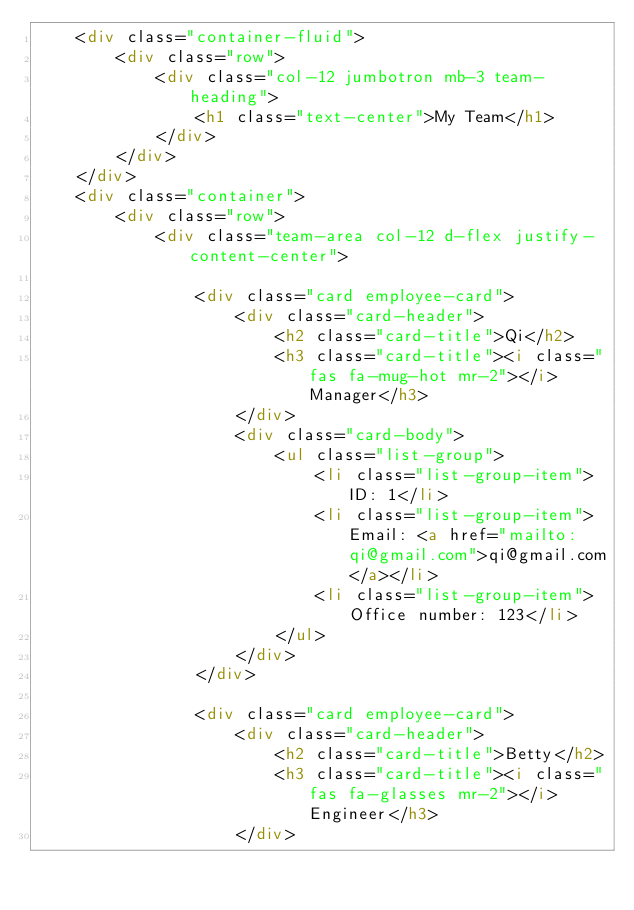<code> <loc_0><loc_0><loc_500><loc_500><_HTML_>    <div class="container-fluid">
        <div class="row">
            <div class="col-12 jumbotron mb-3 team-heading">
                <h1 class="text-center">My Team</h1>
            </div>
        </div>
    </div>
    <div class="container">
        <div class="row">
            <div class="team-area col-12 d-flex justify-content-center">

                <div class="card employee-card">
                    <div class="card-header">
                        <h2 class="card-title">Qi</h2>
                        <h3 class="card-title"><i class="fas fa-mug-hot mr-2"></i>Manager</h3>
                    </div>
                    <div class="card-body">
                        <ul class="list-group">
                            <li class="list-group-item">ID: 1</li>
                            <li class="list-group-item">Email: <a href="mailto:qi@gmail.com">qi@gmail.com</a></li>
                            <li class="list-group-item">Office number: 123</li>
                        </ul>
                    </div>
                </div>

                <div class="card employee-card">
                    <div class="card-header">
                        <h2 class="card-title">Betty</h2>
                        <h3 class="card-title"><i class="fas fa-glasses mr-2"></i>Engineer</h3>
                    </div></code> 